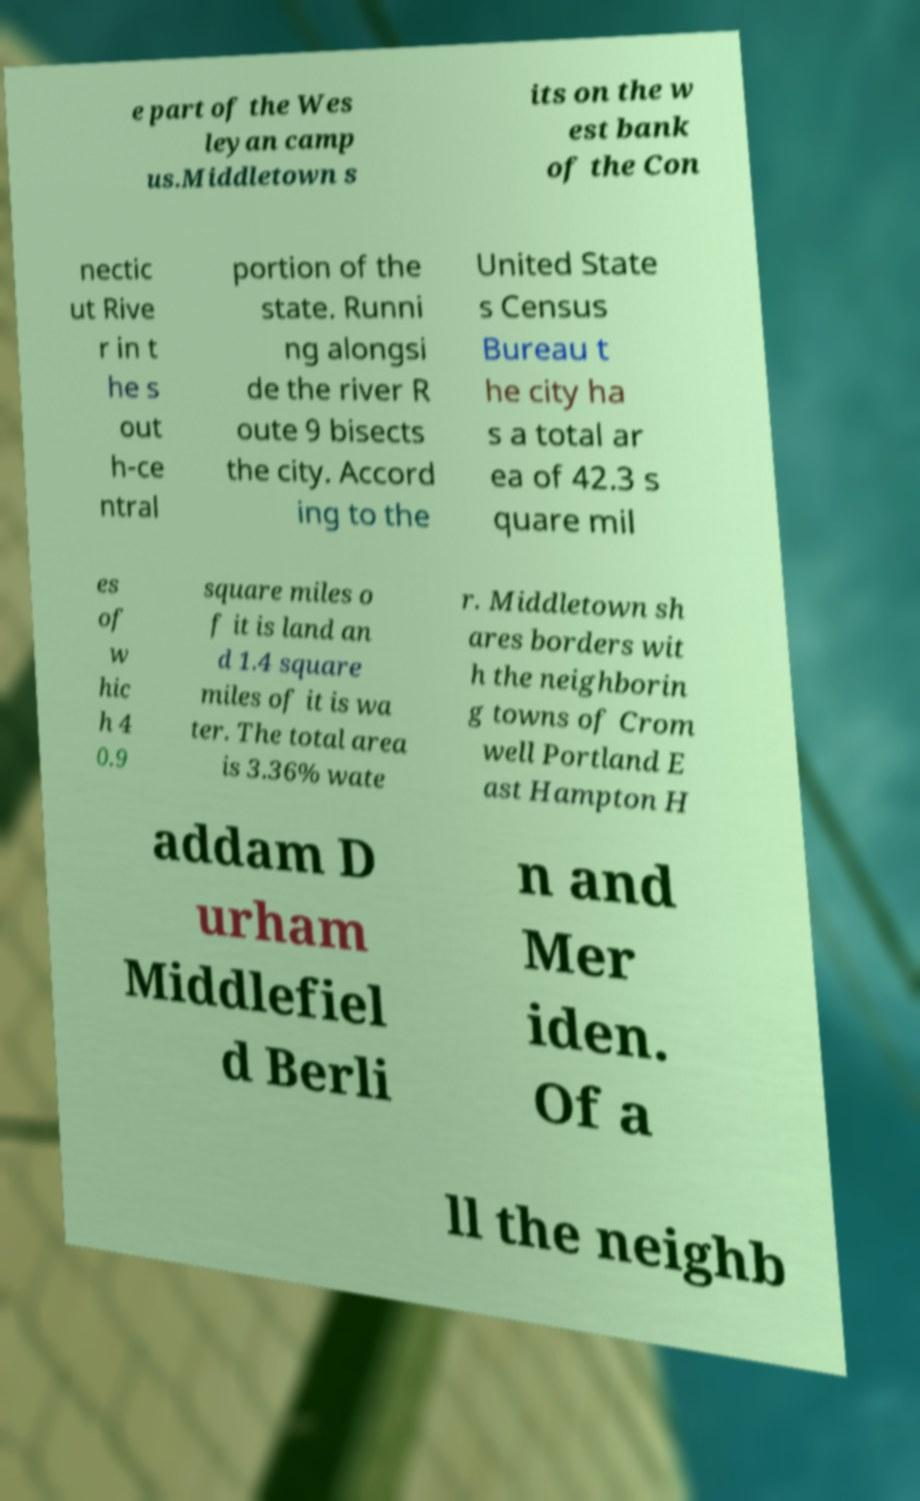What messages or text are displayed in this image? I need them in a readable, typed format. e part of the Wes leyan camp us.Middletown s its on the w est bank of the Con nectic ut Rive r in t he s out h-ce ntral portion of the state. Runni ng alongsi de the river R oute 9 bisects the city. Accord ing to the United State s Census Bureau t he city ha s a total ar ea of 42.3 s quare mil es of w hic h 4 0.9 square miles o f it is land an d 1.4 square miles of it is wa ter. The total area is 3.36% wate r. Middletown sh ares borders wit h the neighborin g towns of Crom well Portland E ast Hampton H addam D urham Middlefiel d Berli n and Mer iden. Of a ll the neighb 